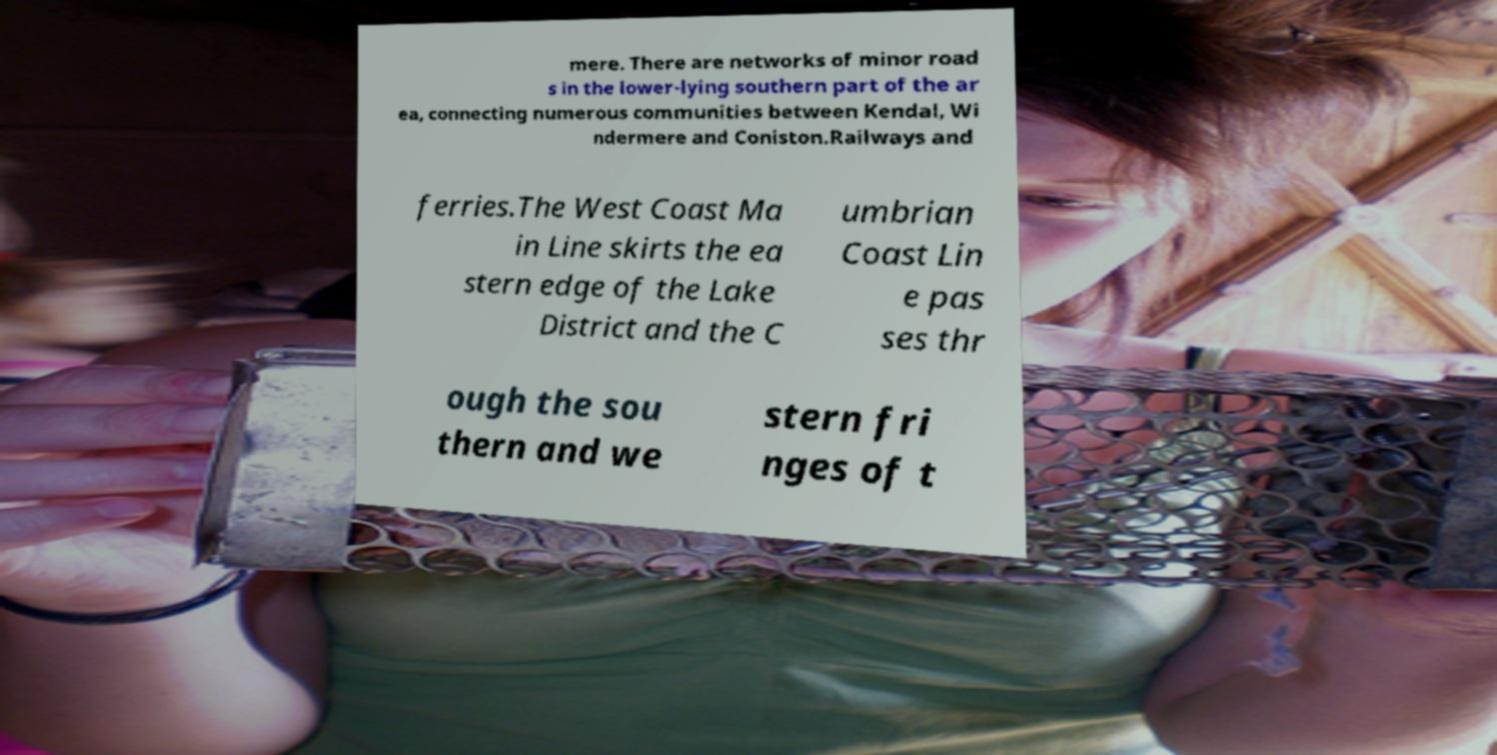Can you accurately transcribe the text from the provided image for me? mere. There are networks of minor road s in the lower-lying southern part of the ar ea, connecting numerous communities between Kendal, Wi ndermere and Coniston.Railways and ferries.The West Coast Ma in Line skirts the ea stern edge of the Lake District and the C umbrian Coast Lin e pas ses thr ough the sou thern and we stern fri nges of t 